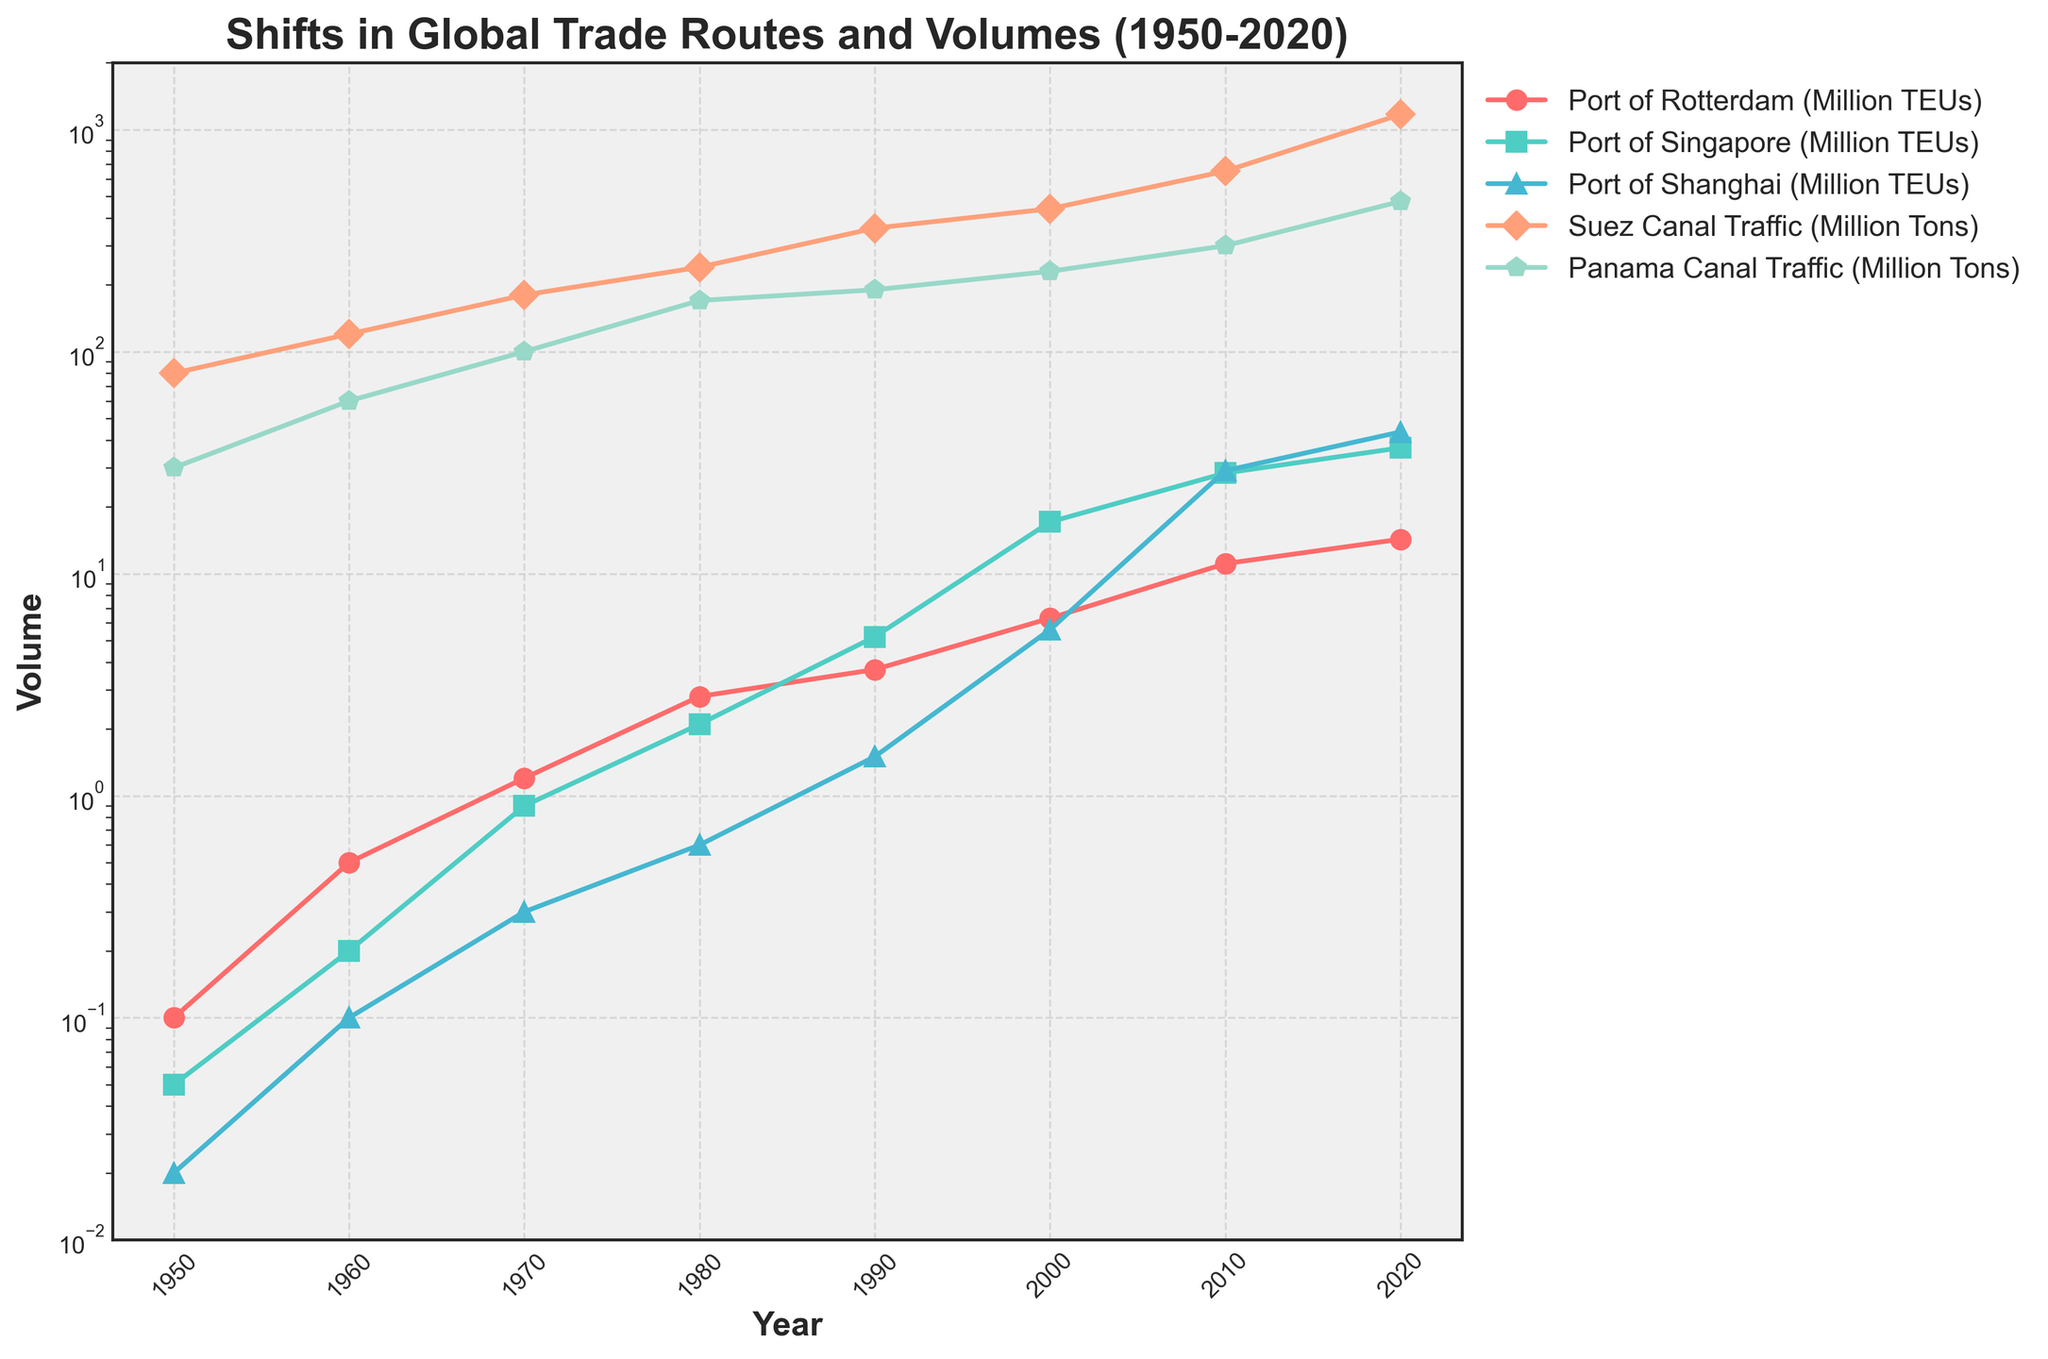What year did the Port of Singapore surpass the Port of Rotterdam in TEU volume? In the figure, observe the lines for both the Port of Singapore and the Port of Rotterdam. The point where the Port of Singapore's line crosses above the Port of Rotterdam's line marks the year it surpassed it. This occurs between 1980 and 1990. Checking these years more closely, the crossover happens in 1990.
Answer: 1990 What is the difference in TEU volume for the Port of Shanghai between 2000 and 2020? Locate the data points for the Port of Shanghai in 2000 and 2020. Subtract the 2000 volume (5.6 Million TEUs) from the 2020 volume (43.5 Million TEUs). 43.5 - 5.6 = 37.9.
Answer: 37.9 Million TEUs How much did Suez Canal traffic grow from 1950 to 2020, in percentage terms? First, get the Suez Canal traffic values for 1950 and 2020: 80 Million Tons and 1170 Million Tons, respectively. Calculate the growth percentage with the formula (1170 - 80) / 80 * 100%. This gives (1170 - 80) / 80 * 100% = 1362.5%.
Answer: 1362.5% Between which two consecutive decades did the Port of Rotterdam see the highest growth rate in TEU volume? Identify the increments in TEU volume between each consecutive decade for the Port of Rotterdam and calculate the growth rates. The highest growth rate is observed between 1960 (0.5 Million TEUs) and 1970 (1.2 Million TEUs), with a growth rate of ((1.2 - 0.5) / 0.5) * 100 = 140%.
Answer: 1960 to 1970 Which port had the highest TEU volume in 2010? Visualize the data points for 2010 and compare the TEU volumes of the three ports (Rotterdam, Singapore, and Shanghai). The Port of Shanghai's line is at the highest point (29.1 Million TEUs).
Answer: Port of Shanghai What is the average growth in Panama Canal traffic per decade from 1950 to 2020? Calculate the total growth of Panama Canal traffic over these years then divide by the number of decades (7). The total growth is 475 - 30 = 445 Million Tons. Thus, the average growth per decade is 445 / 7 ≈ 63.57 Million Tons.
Answer: ~63.57 Million Tons What was the combined TEU volume handled by the Port of Rotterdam and Port of Singapore in 1980? Add the TEU volumes for the Port of Rotterdam (2.8 Million TEUs) and the Port of Singapore (2.1 Million TEUs) in 1980. 2.8 + 2.1 = 4.9 Million TEUs.
Answer: 4.9 Million TEUs By how much did Suez Canal traffic exceed Panama Canal traffic in 2020? Identify the traffic values for both the Suez Canal and Panama Canal in 2020: 1170 Million Tons and 475 Million Tons, respectively. Subtract Panama Canal traffic from Suez Canal traffic. 1170 - 475 = 695 Million Tons.
Answer: 695 Million Tons Which shipping lane experienced the steady growth across the entire period from 1950 to 2020? Examine the trends for the Suez Canal and Panama Canal lines. Both seem to grow steadily, but the Suez Canal shows a more consistent upward trend across the entire period.
Answer: Suez Canal From which decade did the TEU volume for the Port of Shanghai show a significant upward trend? Look at when the Port of Shanghai's volume starts rising sharply. The significant upward trend is noticeable starting from the 1990s.
Answer: 1990s 